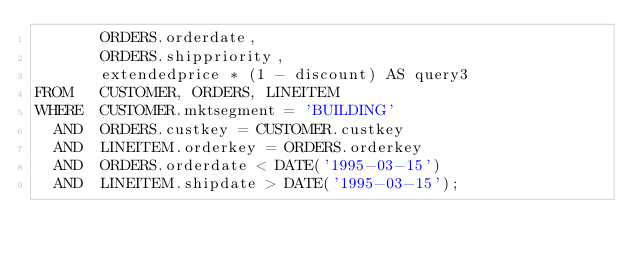<code> <loc_0><loc_0><loc_500><loc_500><_SQL_>       ORDERS.orderdate,
       ORDERS.shippriority,
       extendedprice * (1 - discount) AS query3
FROM   CUSTOMER, ORDERS, LINEITEM
WHERE  CUSTOMER.mktsegment = 'BUILDING'
  AND  ORDERS.custkey = CUSTOMER.custkey
  AND  LINEITEM.orderkey = ORDERS.orderkey
  AND  ORDERS.orderdate < DATE('1995-03-15')
  AND  LINEITEM.shipdate > DATE('1995-03-15');

</code> 